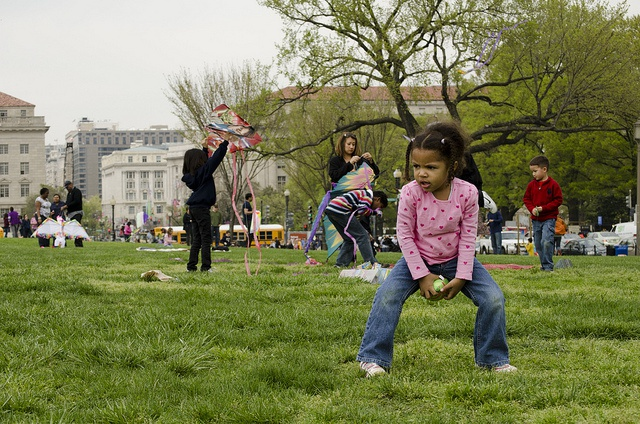Describe the objects in this image and their specific colors. I can see people in lightgray, black, lightpink, and gray tones, people in lightgray, black, darkgray, darkgreen, and olive tones, people in lightgray, gray, black, olive, and darkgray tones, people in lightgray, black, gray, darkgray, and navy tones, and people in lightgray, black, maroon, gray, and darkblue tones in this image. 